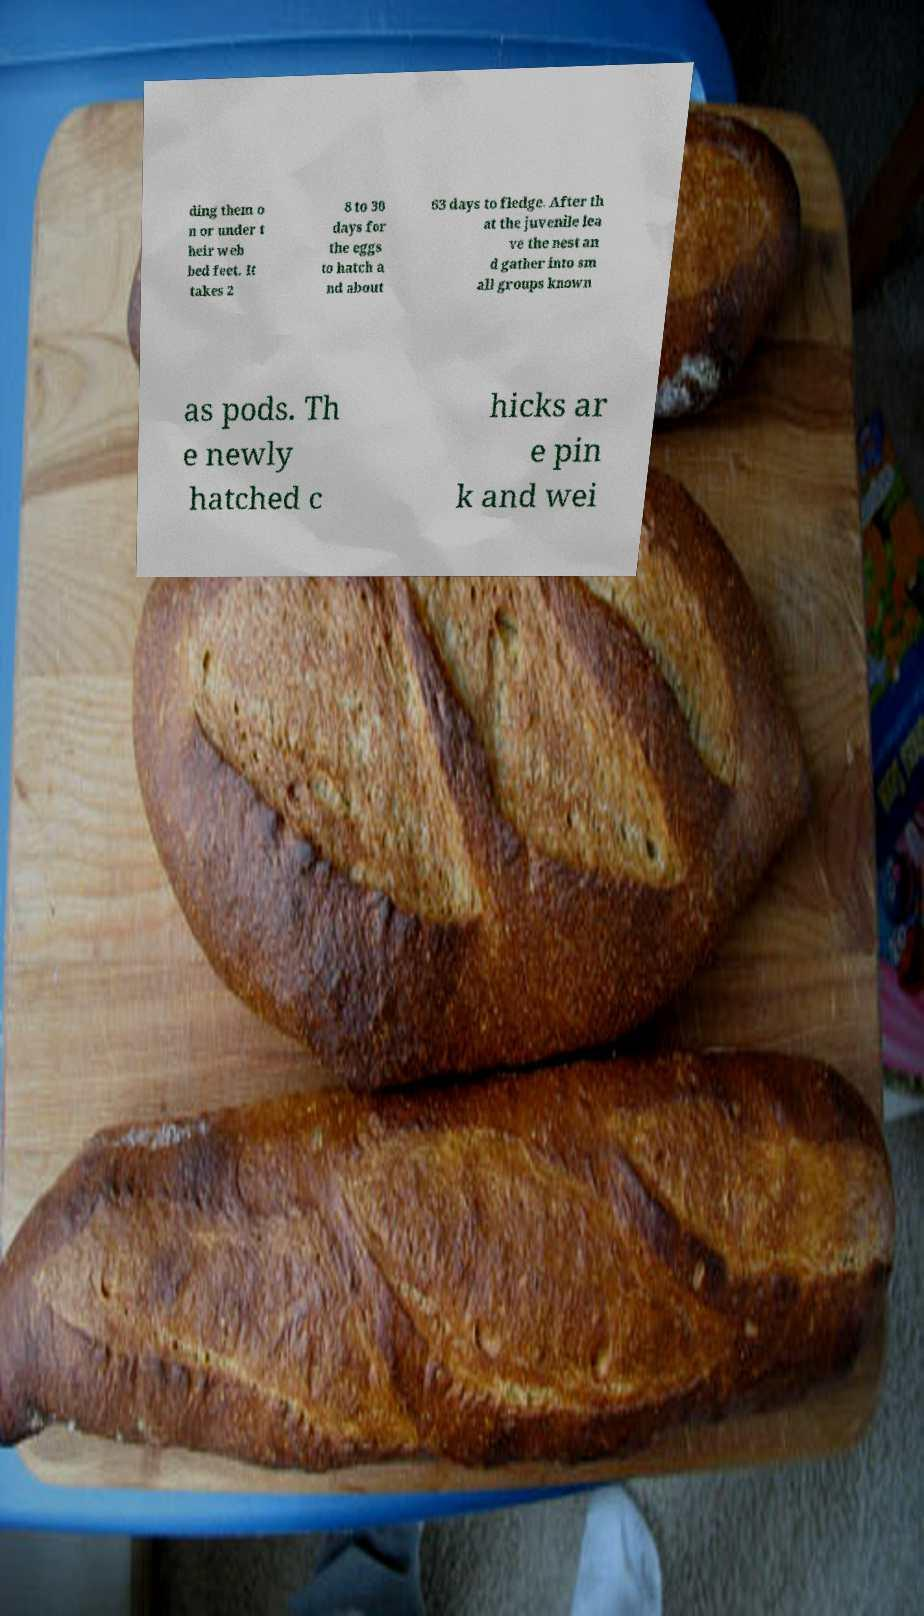I need the written content from this picture converted into text. Can you do that? ding them o n or under t heir web bed feet. It takes 2 8 to 30 days for the eggs to hatch a nd about 63 days to fledge. After th at the juvenile lea ve the nest an d gather into sm all groups known as pods. Th e newly hatched c hicks ar e pin k and wei 